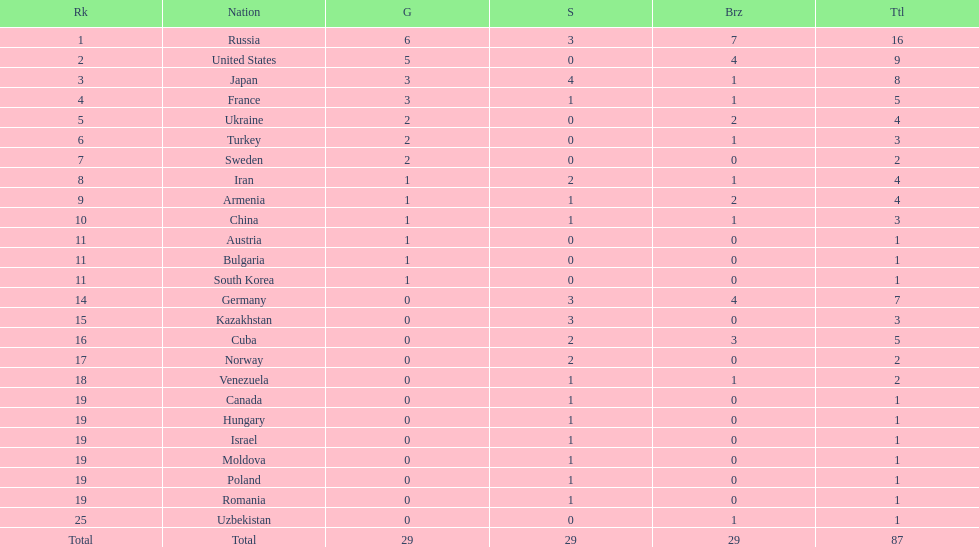How many silver medals did turkey win? 0. 